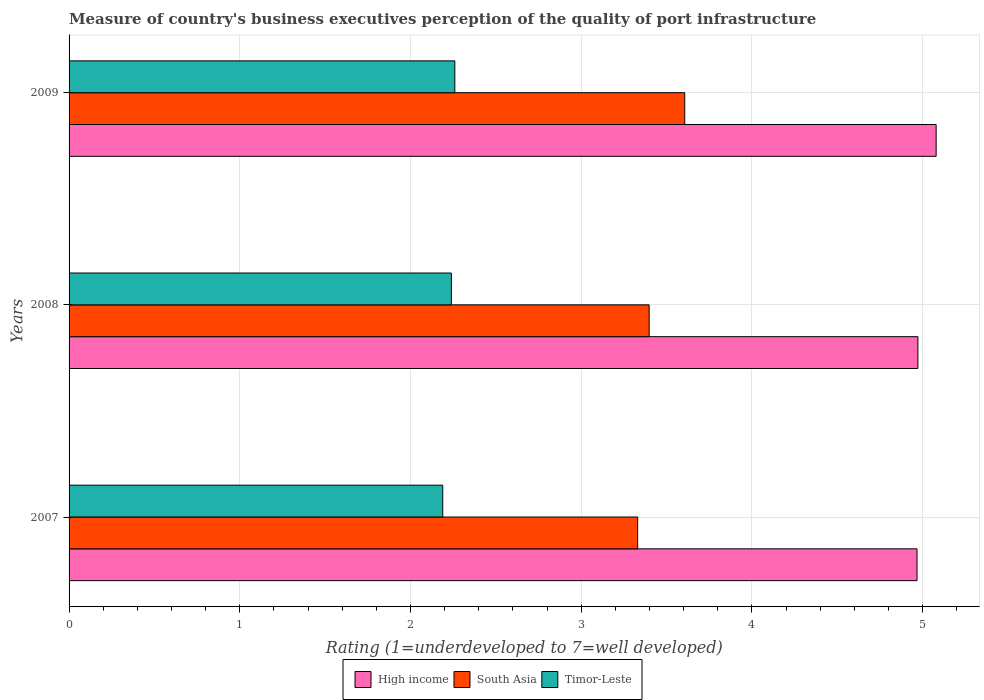How many different coloured bars are there?
Keep it short and to the point. 3. How many groups of bars are there?
Make the answer very short. 3. Are the number of bars per tick equal to the number of legend labels?
Offer a terse response. Yes. What is the label of the 2nd group of bars from the top?
Make the answer very short. 2008. In how many cases, is the number of bars for a given year not equal to the number of legend labels?
Ensure brevity in your answer.  0. What is the ratings of the quality of port infrastructure in High income in 2009?
Your response must be concise. 5.08. Across all years, what is the maximum ratings of the quality of port infrastructure in South Asia?
Give a very brief answer. 3.61. Across all years, what is the minimum ratings of the quality of port infrastructure in High income?
Ensure brevity in your answer.  4.97. In which year was the ratings of the quality of port infrastructure in South Asia minimum?
Provide a succinct answer. 2007. What is the total ratings of the quality of port infrastructure in Timor-Leste in the graph?
Your answer should be compact. 6.69. What is the difference between the ratings of the quality of port infrastructure in South Asia in 2008 and that in 2009?
Your answer should be very brief. -0.21. What is the difference between the ratings of the quality of port infrastructure in South Asia in 2009 and the ratings of the quality of port infrastructure in High income in 2008?
Offer a very short reply. -1.37. What is the average ratings of the quality of port infrastructure in Timor-Leste per year?
Make the answer very short. 2.23. In the year 2009, what is the difference between the ratings of the quality of port infrastructure in Timor-Leste and ratings of the quality of port infrastructure in South Asia?
Your answer should be compact. -1.35. In how many years, is the ratings of the quality of port infrastructure in South Asia greater than 2.4 ?
Offer a terse response. 3. What is the ratio of the ratings of the quality of port infrastructure in Timor-Leste in 2007 to that in 2009?
Give a very brief answer. 0.97. Is the ratings of the quality of port infrastructure in High income in 2007 less than that in 2008?
Your answer should be very brief. Yes. Is the difference between the ratings of the quality of port infrastructure in Timor-Leste in 2008 and 2009 greater than the difference between the ratings of the quality of port infrastructure in South Asia in 2008 and 2009?
Make the answer very short. Yes. What is the difference between the highest and the second highest ratings of the quality of port infrastructure in High income?
Provide a succinct answer. 0.11. What is the difference between the highest and the lowest ratings of the quality of port infrastructure in South Asia?
Keep it short and to the point. 0.28. What does the 3rd bar from the bottom in 2008 represents?
Your answer should be compact. Timor-Leste. Is it the case that in every year, the sum of the ratings of the quality of port infrastructure in High income and ratings of the quality of port infrastructure in Timor-Leste is greater than the ratings of the quality of port infrastructure in South Asia?
Give a very brief answer. Yes. How many bars are there?
Your answer should be compact. 9. How many years are there in the graph?
Make the answer very short. 3. What is the difference between two consecutive major ticks on the X-axis?
Your answer should be compact. 1. Are the values on the major ticks of X-axis written in scientific E-notation?
Your answer should be compact. No. Does the graph contain any zero values?
Your response must be concise. No. How many legend labels are there?
Your response must be concise. 3. How are the legend labels stacked?
Provide a short and direct response. Horizontal. What is the title of the graph?
Make the answer very short. Measure of country's business executives perception of the quality of port infrastructure. Does "Austria" appear as one of the legend labels in the graph?
Your answer should be very brief. No. What is the label or title of the X-axis?
Provide a succinct answer. Rating (1=underdeveloped to 7=well developed). What is the label or title of the Y-axis?
Offer a very short reply. Years. What is the Rating (1=underdeveloped to 7=well developed) of High income in 2007?
Your answer should be very brief. 4.97. What is the Rating (1=underdeveloped to 7=well developed) of South Asia in 2007?
Make the answer very short. 3.33. What is the Rating (1=underdeveloped to 7=well developed) of Timor-Leste in 2007?
Give a very brief answer. 2.19. What is the Rating (1=underdeveloped to 7=well developed) in High income in 2008?
Offer a very short reply. 4.97. What is the Rating (1=underdeveloped to 7=well developed) in South Asia in 2008?
Offer a very short reply. 3.4. What is the Rating (1=underdeveloped to 7=well developed) in Timor-Leste in 2008?
Your answer should be very brief. 2.24. What is the Rating (1=underdeveloped to 7=well developed) in High income in 2009?
Ensure brevity in your answer.  5.08. What is the Rating (1=underdeveloped to 7=well developed) in South Asia in 2009?
Provide a succinct answer. 3.61. What is the Rating (1=underdeveloped to 7=well developed) of Timor-Leste in 2009?
Give a very brief answer. 2.26. Across all years, what is the maximum Rating (1=underdeveloped to 7=well developed) of High income?
Your answer should be compact. 5.08. Across all years, what is the maximum Rating (1=underdeveloped to 7=well developed) of South Asia?
Make the answer very short. 3.61. Across all years, what is the maximum Rating (1=underdeveloped to 7=well developed) of Timor-Leste?
Make the answer very short. 2.26. Across all years, what is the minimum Rating (1=underdeveloped to 7=well developed) of High income?
Offer a very short reply. 4.97. Across all years, what is the minimum Rating (1=underdeveloped to 7=well developed) of South Asia?
Offer a terse response. 3.33. Across all years, what is the minimum Rating (1=underdeveloped to 7=well developed) of Timor-Leste?
Keep it short and to the point. 2.19. What is the total Rating (1=underdeveloped to 7=well developed) in High income in the graph?
Your response must be concise. 15.02. What is the total Rating (1=underdeveloped to 7=well developed) of South Asia in the graph?
Provide a succinct answer. 10.34. What is the total Rating (1=underdeveloped to 7=well developed) of Timor-Leste in the graph?
Offer a terse response. 6.69. What is the difference between the Rating (1=underdeveloped to 7=well developed) of High income in 2007 and that in 2008?
Offer a terse response. -0.01. What is the difference between the Rating (1=underdeveloped to 7=well developed) in South Asia in 2007 and that in 2008?
Your answer should be very brief. -0.07. What is the difference between the Rating (1=underdeveloped to 7=well developed) of Timor-Leste in 2007 and that in 2008?
Ensure brevity in your answer.  -0.05. What is the difference between the Rating (1=underdeveloped to 7=well developed) of High income in 2007 and that in 2009?
Offer a terse response. -0.11. What is the difference between the Rating (1=underdeveloped to 7=well developed) of South Asia in 2007 and that in 2009?
Give a very brief answer. -0.28. What is the difference between the Rating (1=underdeveloped to 7=well developed) of Timor-Leste in 2007 and that in 2009?
Offer a terse response. -0.07. What is the difference between the Rating (1=underdeveloped to 7=well developed) of High income in 2008 and that in 2009?
Make the answer very short. -0.11. What is the difference between the Rating (1=underdeveloped to 7=well developed) of South Asia in 2008 and that in 2009?
Make the answer very short. -0.21. What is the difference between the Rating (1=underdeveloped to 7=well developed) of Timor-Leste in 2008 and that in 2009?
Give a very brief answer. -0.02. What is the difference between the Rating (1=underdeveloped to 7=well developed) in High income in 2007 and the Rating (1=underdeveloped to 7=well developed) in South Asia in 2008?
Offer a terse response. 1.57. What is the difference between the Rating (1=underdeveloped to 7=well developed) in High income in 2007 and the Rating (1=underdeveloped to 7=well developed) in Timor-Leste in 2008?
Provide a succinct answer. 2.73. What is the difference between the Rating (1=underdeveloped to 7=well developed) of South Asia in 2007 and the Rating (1=underdeveloped to 7=well developed) of Timor-Leste in 2008?
Provide a succinct answer. 1.09. What is the difference between the Rating (1=underdeveloped to 7=well developed) in High income in 2007 and the Rating (1=underdeveloped to 7=well developed) in South Asia in 2009?
Offer a terse response. 1.36. What is the difference between the Rating (1=underdeveloped to 7=well developed) of High income in 2007 and the Rating (1=underdeveloped to 7=well developed) of Timor-Leste in 2009?
Offer a very short reply. 2.71. What is the difference between the Rating (1=underdeveloped to 7=well developed) in South Asia in 2007 and the Rating (1=underdeveloped to 7=well developed) in Timor-Leste in 2009?
Your answer should be compact. 1.07. What is the difference between the Rating (1=underdeveloped to 7=well developed) in High income in 2008 and the Rating (1=underdeveloped to 7=well developed) in South Asia in 2009?
Your response must be concise. 1.37. What is the difference between the Rating (1=underdeveloped to 7=well developed) of High income in 2008 and the Rating (1=underdeveloped to 7=well developed) of Timor-Leste in 2009?
Offer a terse response. 2.71. What is the difference between the Rating (1=underdeveloped to 7=well developed) of South Asia in 2008 and the Rating (1=underdeveloped to 7=well developed) of Timor-Leste in 2009?
Your answer should be very brief. 1.14. What is the average Rating (1=underdeveloped to 7=well developed) in High income per year?
Offer a very short reply. 5.01. What is the average Rating (1=underdeveloped to 7=well developed) of South Asia per year?
Offer a very short reply. 3.44. What is the average Rating (1=underdeveloped to 7=well developed) in Timor-Leste per year?
Ensure brevity in your answer.  2.23. In the year 2007, what is the difference between the Rating (1=underdeveloped to 7=well developed) in High income and Rating (1=underdeveloped to 7=well developed) in South Asia?
Keep it short and to the point. 1.64. In the year 2007, what is the difference between the Rating (1=underdeveloped to 7=well developed) in High income and Rating (1=underdeveloped to 7=well developed) in Timor-Leste?
Give a very brief answer. 2.78. In the year 2007, what is the difference between the Rating (1=underdeveloped to 7=well developed) in South Asia and Rating (1=underdeveloped to 7=well developed) in Timor-Leste?
Keep it short and to the point. 1.14. In the year 2008, what is the difference between the Rating (1=underdeveloped to 7=well developed) in High income and Rating (1=underdeveloped to 7=well developed) in South Asia?
Provide a succinct answer. 1.57. In the year 2008, what is the difference between the Rating (1=underdeveloped to 7=well developed) of High income and Rating (1=underdeveloped to 7=well developed) of Timor-Leste?
Make the answer very short. 2.73. In the year 2008, what is the difference between the Rating (1=underdeveloped to 7=well developed) of South Asia and Rating (1=underdeveloped to 7=well developed) of Timor-Leste?
Offer a terse response. 1.16. In the year 2009, what is the difference between the Rating (1=underdeveloped to 7=well developed) in High income and Rating (1=underdeveloped to 7=well developed) in South Asia?
Your response must be concise. 1.47. In the year 2009, what is the difference between the Rating (1=underdeveloped to 7=well developed) in High income and Rating (1=underdeveloped to 7=well developed) in Timor-Leste?
Provide a short and direct response. 2.82. In the year 2009, what is the difference between the Rating (1=underdeveloped to 7=well developed) of South Asia and Rating (1=underdeveloped to 7=well developed) of Timor-Leste?
Make the answer very short. 1.35. What is the ratio of the Rating (1=underdeveloped to 7=well developed) in High income in 2007 to that in 2008?
Ensure brevity in your answer.  1. What is the ratio of the Rating (1=underdeveloped to 7=well developed) of South Asia in 2007 to that in 2008?
Your answer should be very brief. 0.98. What is the ratio of the Rating (1=underdeveloped to 7=well developed) in Timor-Leste in 2007 to that in 2008?
Give a very brief answer. 0.98. What is the ratio of the Rating (1=underdeveloped to 7=well developed) of High income in 2007 to that in 2009?
Make the answer very short. 0.98. What is the ratio of the Rating (1=underdeveloped to 7=well developed) of South Asia in 2007 to that in 2009?
Give a very brief answer. 0.92. What is the ratio of the Rating (1=underdeveloped to 7=well developed) in Timor-Leste in 2007 to that in 2009?
Offer a very short reply. 0.97. What is the ratio of the Rating (1=underdeveloped to 7=well developed) of South Asia in 2008 to that in 2009?
Offer a very short reply. 0.94. What is the ratio of the Rating (1=underdeveloped to 7=well developed) in Timor-Leste in 2008 to that in 2009?
Your response must be concise. 0.99. What is the difference between the highest and the second highest Rating (1=underdeveloped to 7=well developed) of High income?
Provide a succinct answer. 0.11. What is the difference between the highest and the second highest Rating (1=underdeveloped to 7=well developed) in South Asia?
Provide a short and direct response. 0.21. What is the difference between the highest and the second highest Rating (1=underdeveloped to 7=well developed) in Timor-Leste?
Provide a short and direct response. 0.02. What is the difference between the highest and the lowest Rating (1=underdeveloped to 7=well developed) of High income?
Keep it short and to the point. 0.11. What is the difference between the highest and the lowest Rating (1=underdeveloped to 7=well developed) of South Asia?
Your answer should be compact. 0.28. What is the difference between the highest and the lowest Rating (1=underdeveloped to 7=well developed) in Timor-Leste?
Provide a succinct answer. 0.07. 